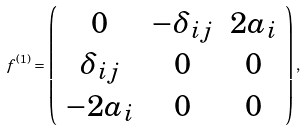<formula> <loc_0><loc_0><loc_500><loc_500>f ^ { ( 1 ) } = \left ( \begin{array} { c c c } 0 & - \delta _ { i j } & 2 a _ { i } \\ \delta _ { i j } & 0 & 0 \\ - 2 a _ { i } & 0 & 0 \end{array} \right ) ,</formula> 